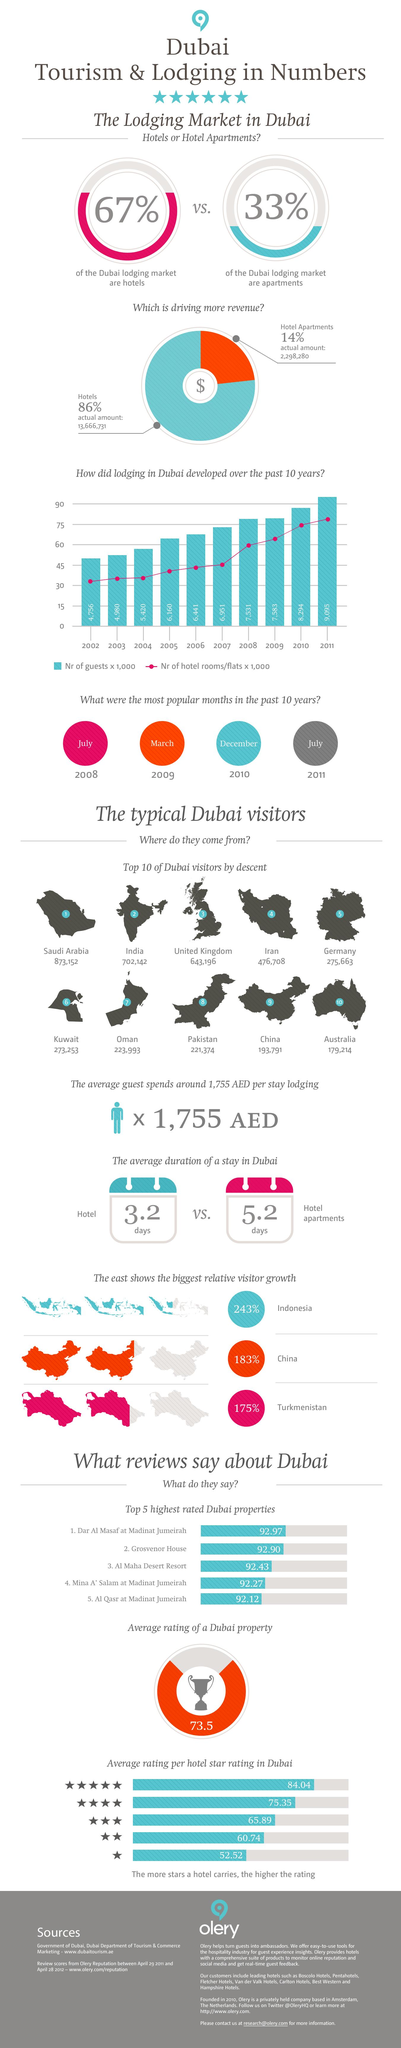List a handful of essential elements in this visual. The number of visitors from India is 702,142. Hotel apartments have the highest share compared to hotels. According to the provided data, there were 223,993 visitors from Oman in the given period. As of December 2021, the number of visitors from Iran was recorded as 476,708. Approximately 33% of the lodging market in Dubai is made up of apartments. 